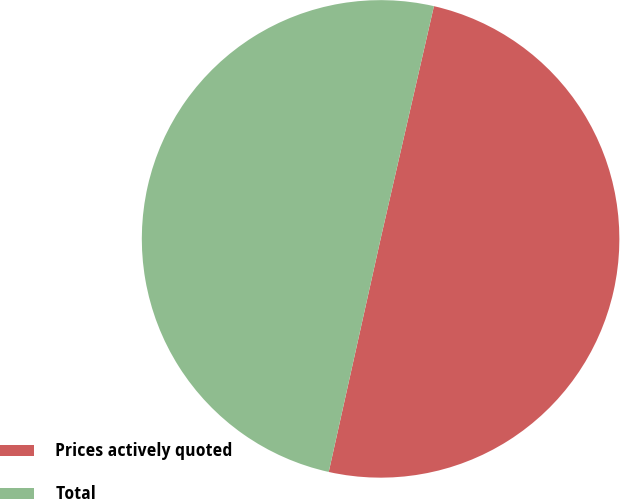Convert chart. <chart><loc_0><loc_0><loc_500><loc_500><pie_chart><fcel>Prices actively quoted<fcel>Total<nl><fcel>49.9%<fcel>50.1%<nl></chart> 